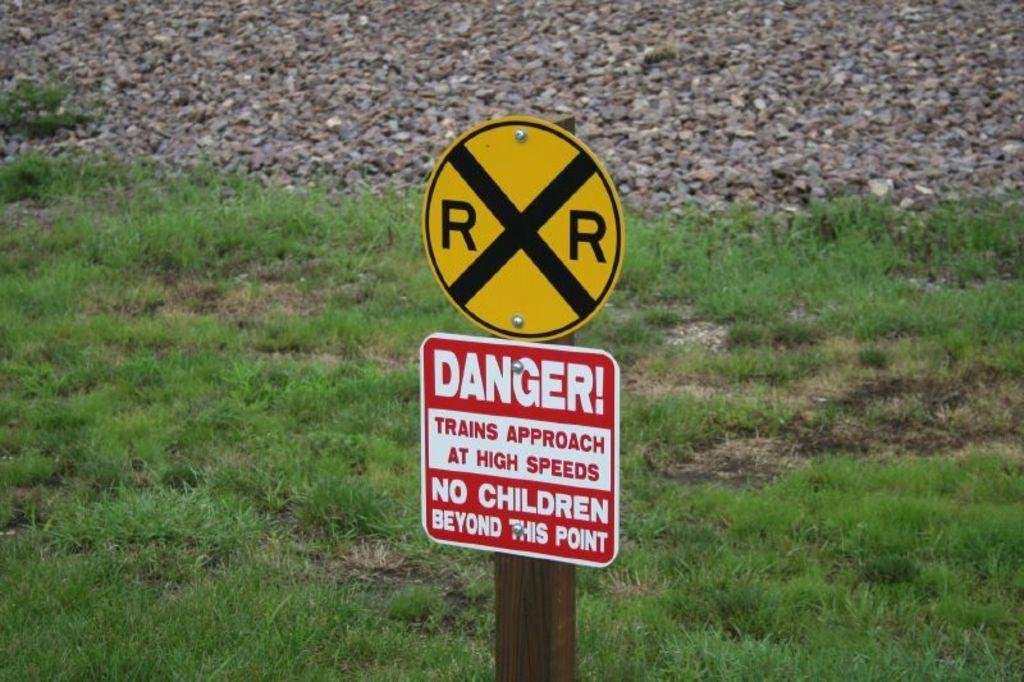Provide a one-sentence caption for the provided image. A railroad crossing sign has a danger sign below it forbidding children to pass. 